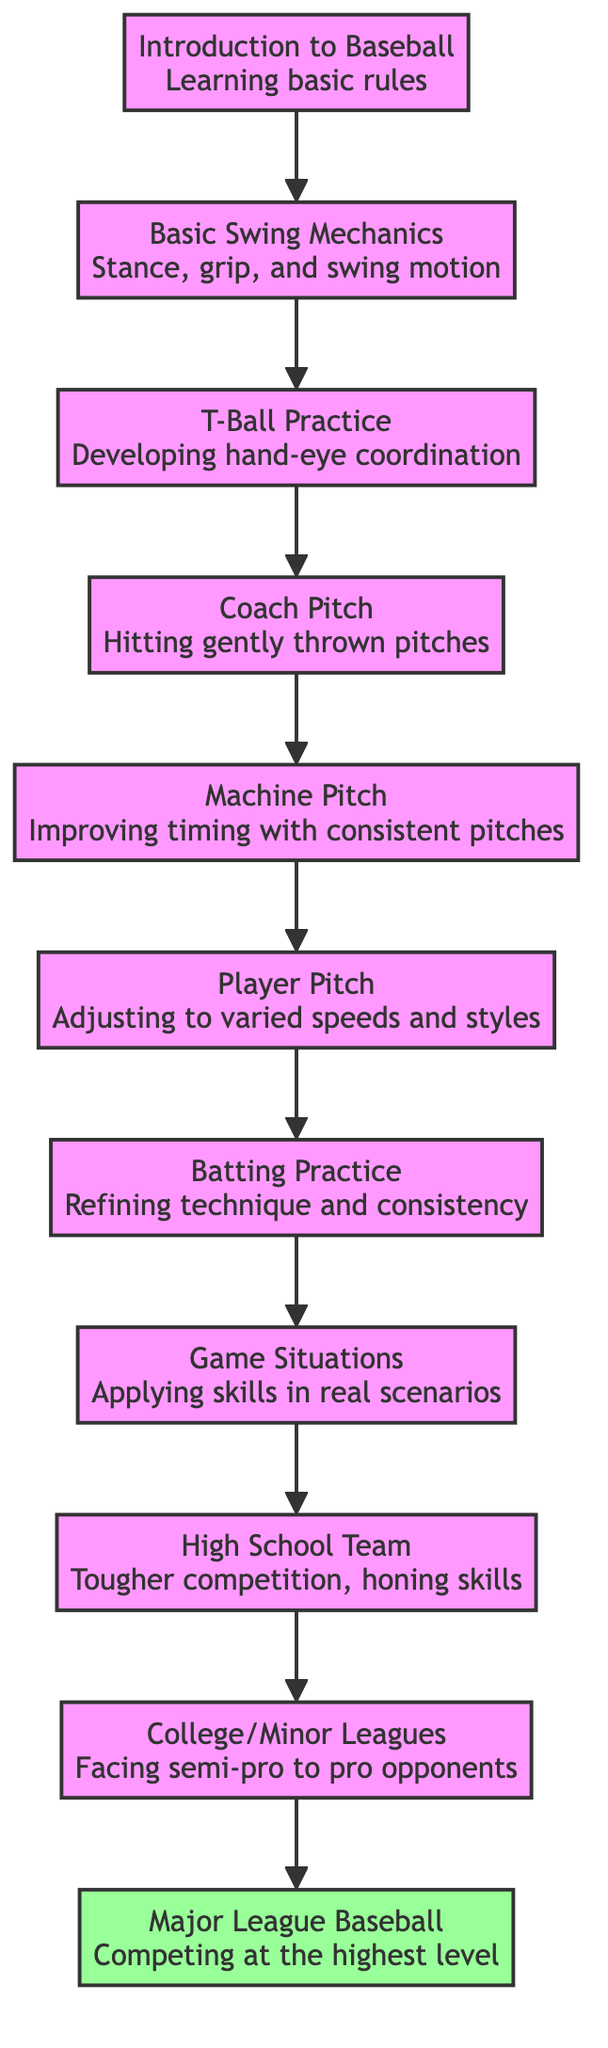What is the highest level in this flow chart? The flow chart progresses from the bottom to the top, and the highest level is represented by node 11, which is "Major League Baseball."
Answer: Major League Baseball How many levels are there in the flow chart? There are a total of 11 levels, as demonstrated by the nodes numbered from 1 through 11.
Answer: 11 What comes before Batting Practice? By tracing the flow upwards, Batting Practice (level 7) is preceded by Player Pitch (level 6).
Answer: Player Pitch What is the title of level 5? Level 5 is represented by the node titled "Machine Pitch."
Answer: Machine Pitch Which level involves applying skills in real-game scenarios? Level 8 specifically focuses on applying skills in real-game scenarios and is labeled as "Game Situations."
Answer: Game Situations What are the first two levels in the flow chart? The first two levels are represented by nodes 1 and 2, labeled "Introduction to Baseball" and "Basic Swing Mechanics," respectively.
Answer: Introduction to Baseball, Basic Swing Mechanics What is the progression from T-Ball Practice to higher levels? Starting at T-Ball Practice (level 3), the progression continues to Coach Pitch (level 4), then Machine Pitch (level 5), Player Pitch (level 6), and eventually to Batting Practice (level 7).
Answer: Coach Pitch, Machine Pitch, Player Pitch, Batting Practice At which level do players face tougher competition? Players face tougher competition at level 9, which is labeled "High School Team."
Answer: High School Team What specific skill is developed in T-Ball Practice? In T-Ball Practice, the specific skill being developed is hand-eye coordination as players hit stationary balls off a tee.
Answer: Hand-eye coordination 